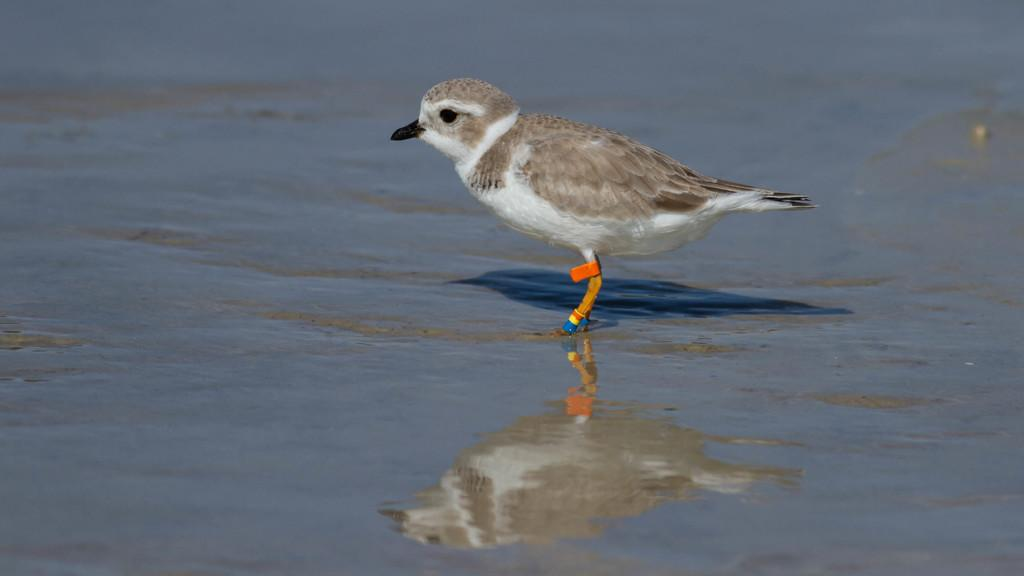What type of animal can be seen in the image? There is a bird in the image. Where is the bird located in the image? The bird is standing in the water. What type of coil is visible in the image? There is no coil present in the image. Can you see the bird's veins in the image? The image does not show the bird's veins; it only shows the bird standing in the water. 